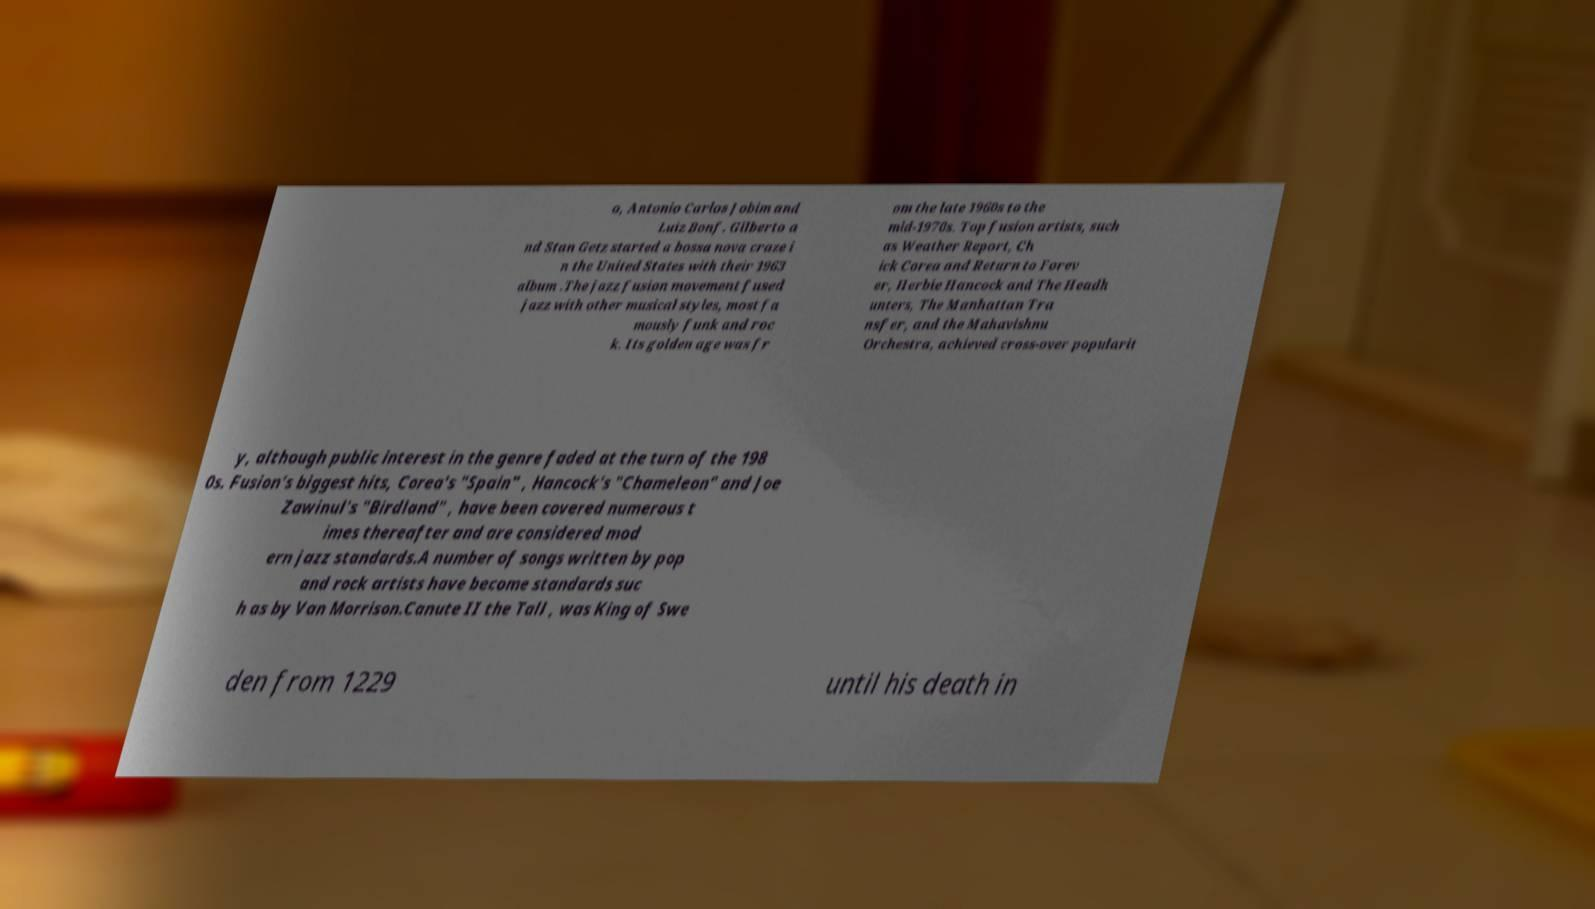Could you assist in decoding the text presented in this image and type it out clearly? o, Antonio Carlos Jobim and Luiz Bonf. Gilberto a nd Stan Getz started a bossa nova craze i n the United States with their 1963 album .The jazz fusion movement fused jazz with other musical styles, most fa mously funk and roc k. Its golden age was fr om the late 1960s to the mid-1970s. Top fusion artists, such as Weather Report, Ch ick Corea and Return to Forev er, Herbie Hancock and The Headh unters, The Manhattan Tra nsfer, and the Mahavishnu Orchestra, achieved cross-over popularit y, although public interest in the genre faded at the turn of the 198 0s. Fusion's biggest hits, Corea's "Spain" , Hancock's "Chameleon" and Joe Zawinul's "Birdland" , have been covered numerous t imes thereafter and are considered mod ern jazz standards.A number of songs written by pop and rock artists have become standards suc h as by Van Morrison.Canute II the Tall , was King of Swe den from 1229 until his death in 